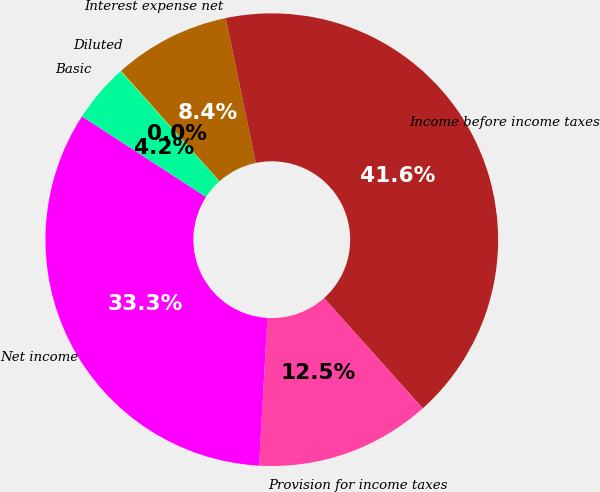Convert chart. <chart><loc_0><loc_0><loc_500><loc_500><pie_chart><fcel>Interest expense net<fcel>Income before income taxes<fcel>Provision for income taxes<fcel>Net income<fcel>Basic<fcel>Diluted<nl><fcel>8.35%<fcel>41.64%<fcel>12.51%<fcel>33.28%<fcel>4.19%<fcel>0.03%<nl></chart> 